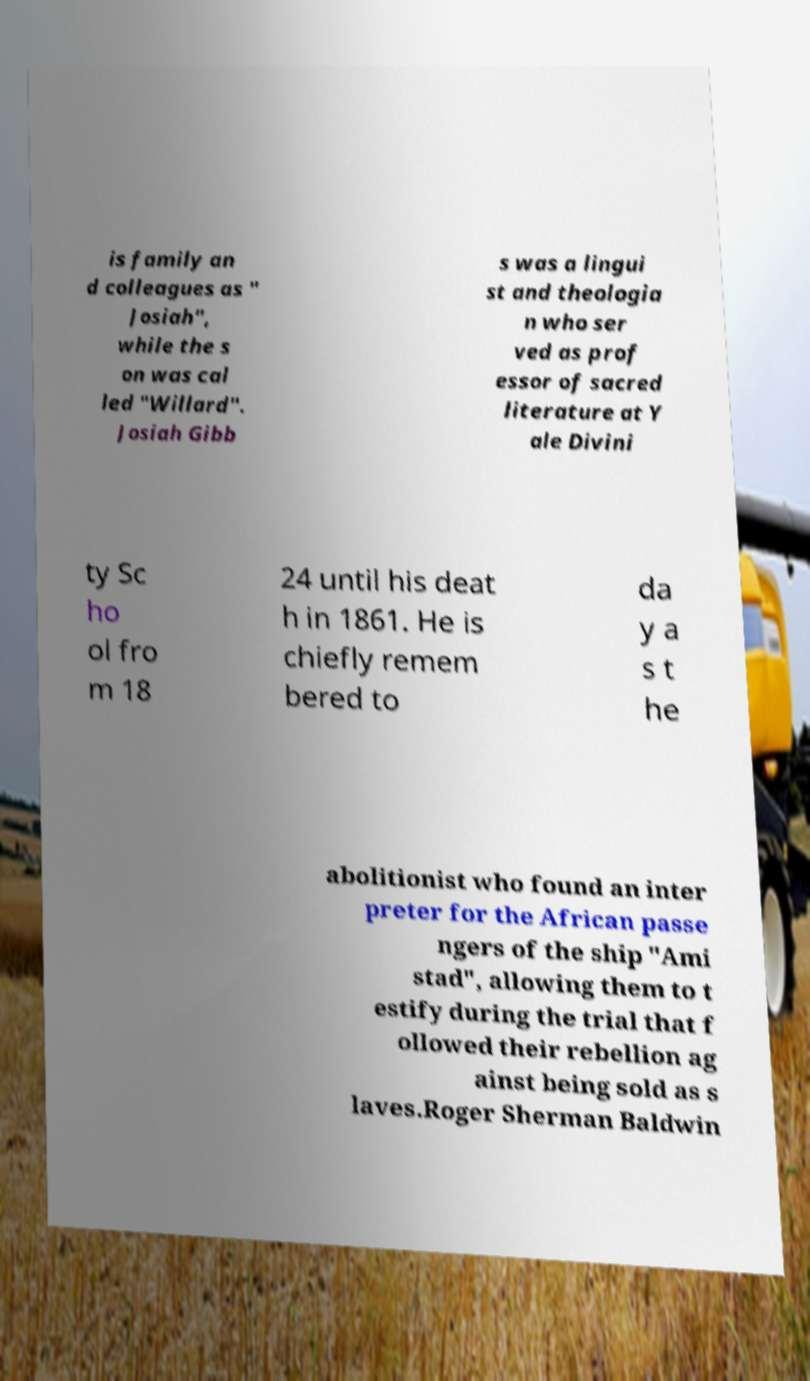Please identify and transcribe the text found in this image. is family an d colleagues as " Josiah", while the s on was cal led "Willard". Josiah Gibb s was a lingui st and theologia n who ser ved as prof essor of sacred literature at Y ale Divini ty Sc ho ol fro m 18 24 until his deat h in 1861. He is chiefly remem bered to da y a s t he abolitionist who found an inter preter for the African passe ngers of the ship "Ami stad", allowing them to t estify during the trial that f ollowed their rebellion ag ainst being sold as s laves.Roger Sherman Baldwin 